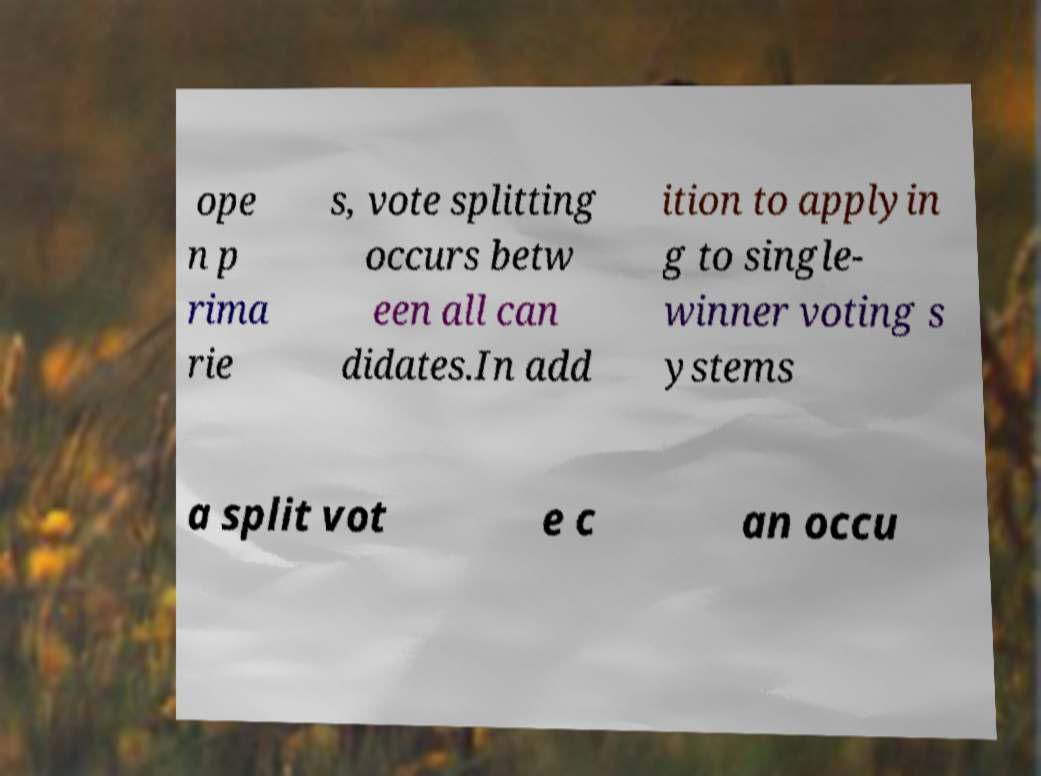Can you accurately transcribe the text from the provided image for me? ope n p rima rie s, vote splitting occurs betw een all can didates.In add ition to applyin g to single- winner voting s ystems a split vot e c an occu 